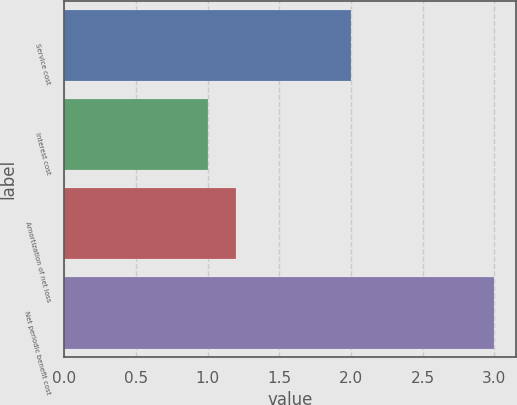Convert chart. <chart><loc_0><loc_0><loc_500><loc_500><bar_chart><fcel>Service cost<fcel>Interest cost<fcel>Amortization of net loss<fcel>Net periodic benefit cost<nl><fcel>2<fcel>1<fcel>1.2<fcel>3<nl></chart> 